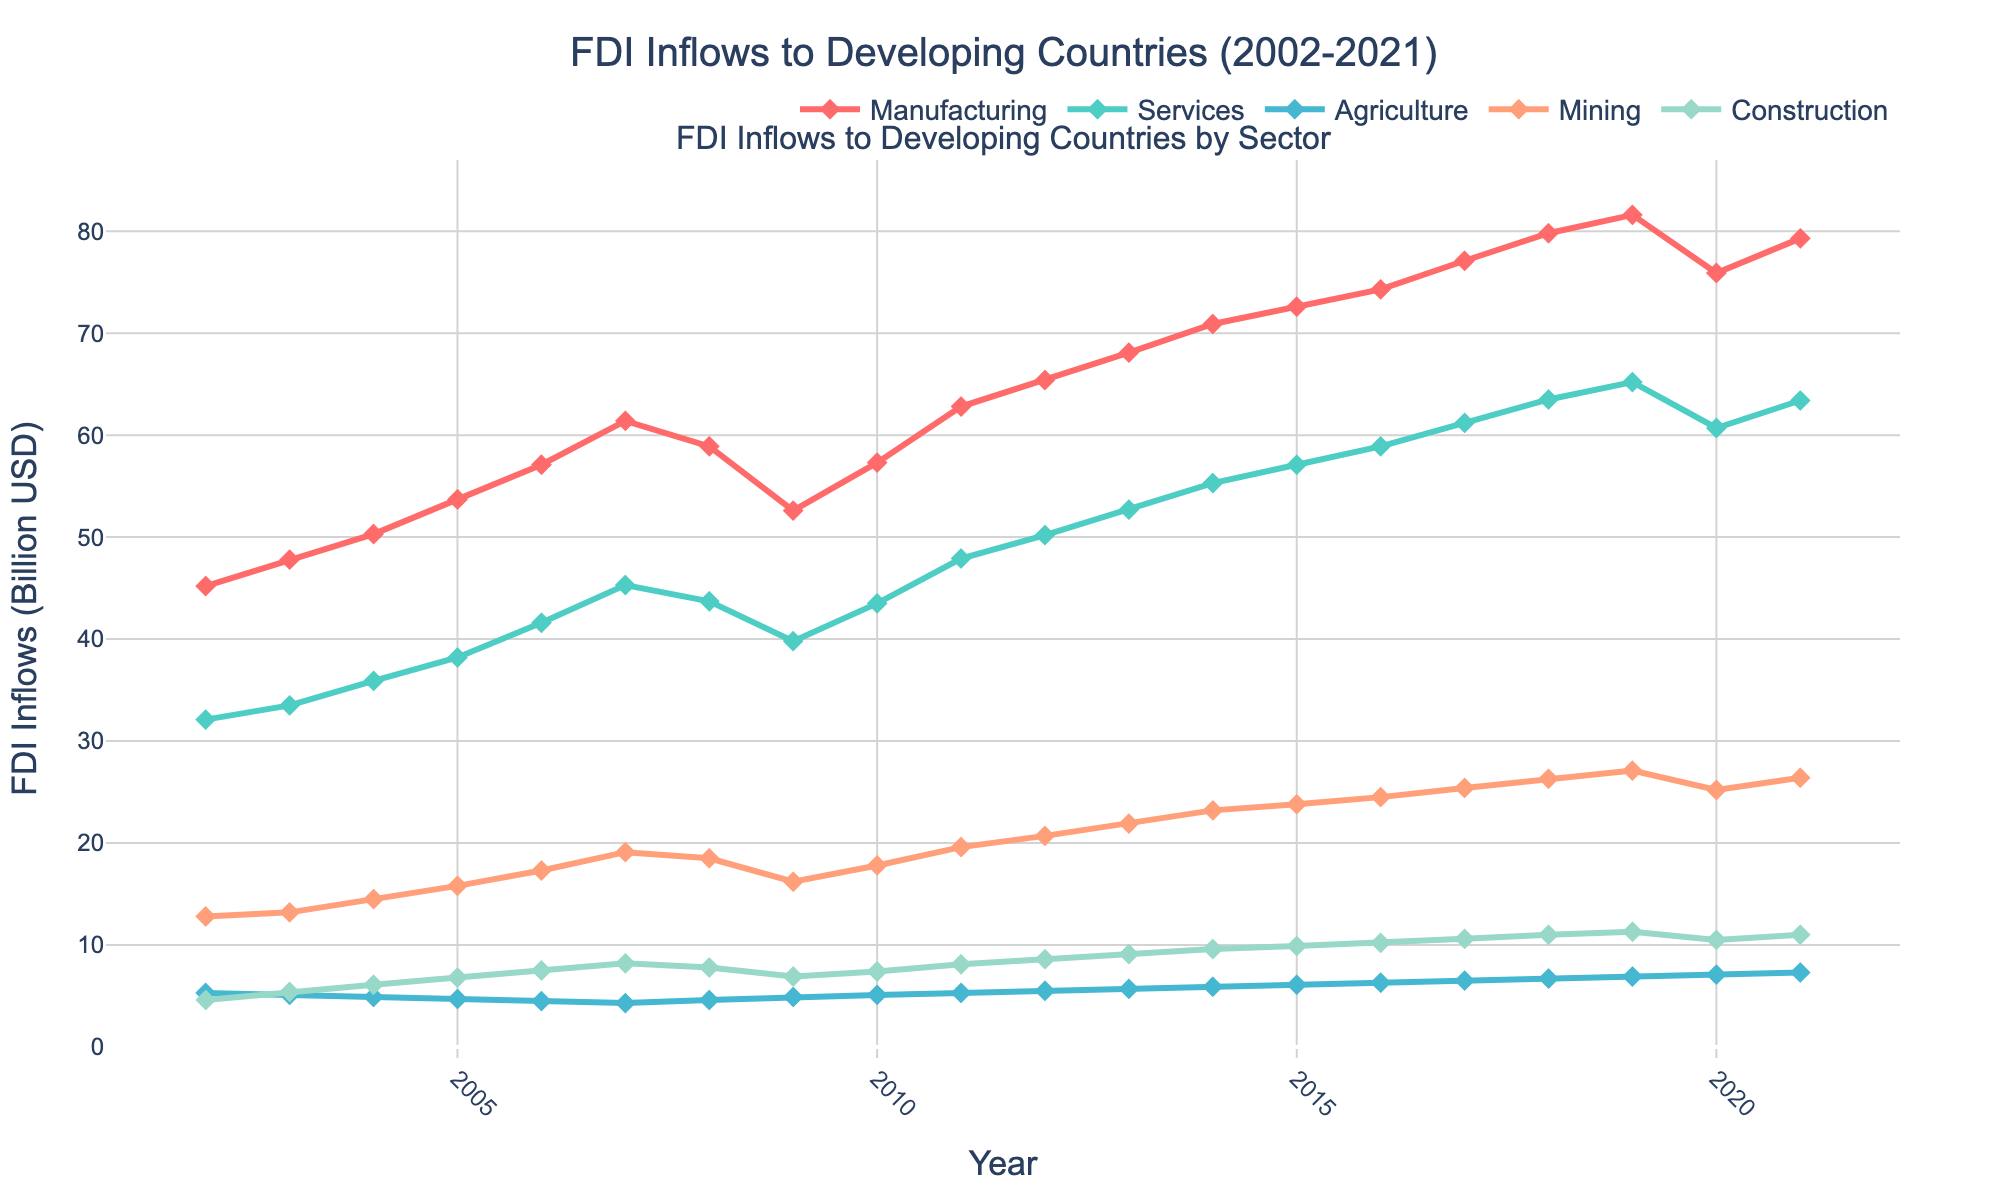What trend do we see in the Manufacturing sector's FDI inflows over the period? The trend in the manufacturing sector's FDI inflows can be observed by looking at the line representing the manufacturing sector, which continuously rises from 45.2 billion USD in 2002 to a peak of 81.6 billion USD in 2019, with a slight dip in 2020 and a recovery in 2021.
Answer: Increasing Which sector had the highest FDI inflow in 2021? To find the sector with the highest FDI inflow in 2021, we compare the values of all sectors in that year. Manufacturing had the highest inflow with 79.3 billion USD.
Answer: Manufacturing Between which two years did the Services sector see the largest increase in FDI inflows? To find the largest increase, we analyze the year-over-year changes in the Services sector. The largest increase occurred between 2005 and 2006, where it increased from 38.2 to 41.6 billion USD.
Answer: 2005-2006 How did the Agriculture sector’s FDI inflows change from 2002 to 2021? By observing the line corresponding to the Agriculture sector, we see that it increased gradually from 5.3 billion USD in 2002 to 7.3 billion USD in 2021.
Answer: Increased Which year had the lowest total FDI inflows across all sectors, and what was the total? We calculate the total FDI inflows for each year by summing up the values across all sectors. The lowest total occurred in 2002 with 100 billion USD (45.2 + 32.1 + 5.3 + 12.8 + 4.6).
Answer: 2002, 100 billion USD In which year did the Mining sector FDI inflows surpass 20 billion USD for the first time? By looking at the values for the Mining sector, we see that it surpassed 20 billion USD in 2012 with 20.7 billion USD.
Answer: 2012 Compare the FDI inflows of the Construction sector in 2009 and 2020. Which year had higher inflows and by how much? Construction sector inflows in 2009 were 6.9 billion USD and in 2020 were 10.5 billion USD. 2020 had higher inflows by 10.5 - 6.9 = 3.6 billion USD.
Answer: 2020, 3.6 billion USD What is the overall trend for the Services sector's FDI inflows from 2002 to 2021? Observing the line for the Services sector, there is a general upward trend starting at 32.1 billion USD in 2002 and reaching 63.4 billion USD in 2021.
Answer: Increasing What are the FDI inflows in the Manufacturing sector and the Services sector in 2007, and which one is higher? Checking the values for 2007, the Manufacturing sector had an inflow of 61.4 billion USD, while the Services sector had 45.3 billion USD. Manufacturing was higher.
Answer: Manufacturing 